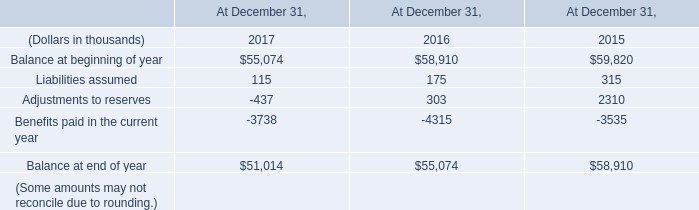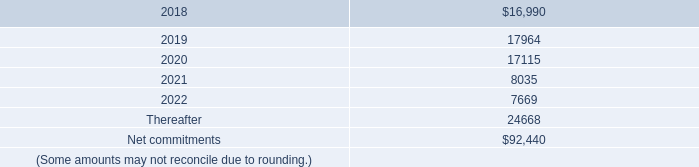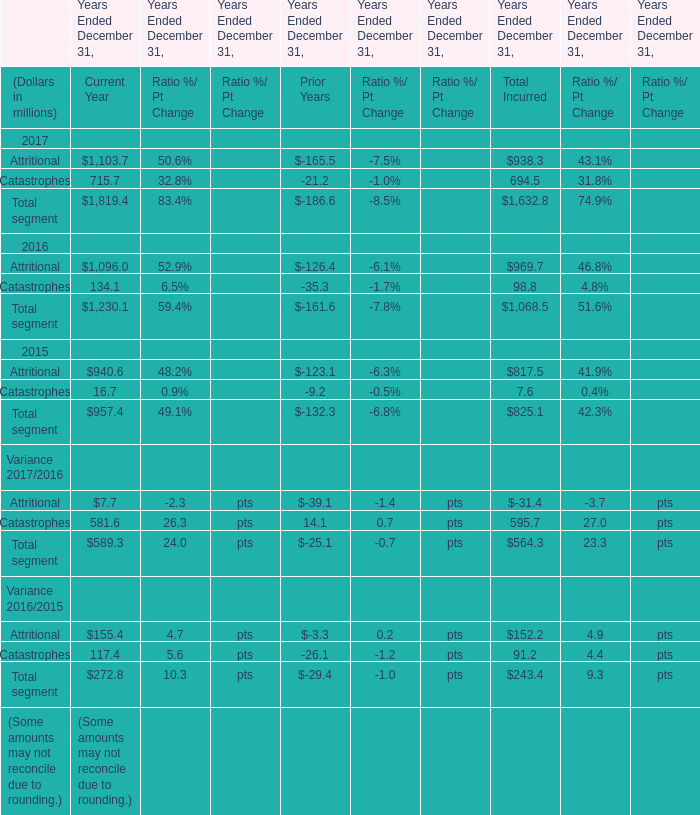what was the total value of notes issued by kilimanjaro in 2014 in thousands 
Computations: (500000 + 450000)
Answer: 950000.0. 